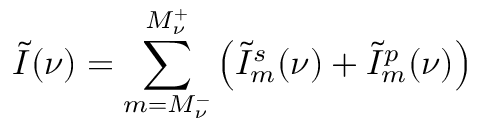Convert formula to latex. <formula><loc_0><loc_0><loc_500><loc_500>\tilde { I } ( \nu ) = \sum _ { m = M _ { \nu } ^ { - } } ^ { M _ { \nu } ^ { + } } \left ( \tilde { I } _ { m } ^ { s } ( \nu ) + \tilde { I } _ { m } ^ { p } ( \nu ) \right )</formula> 